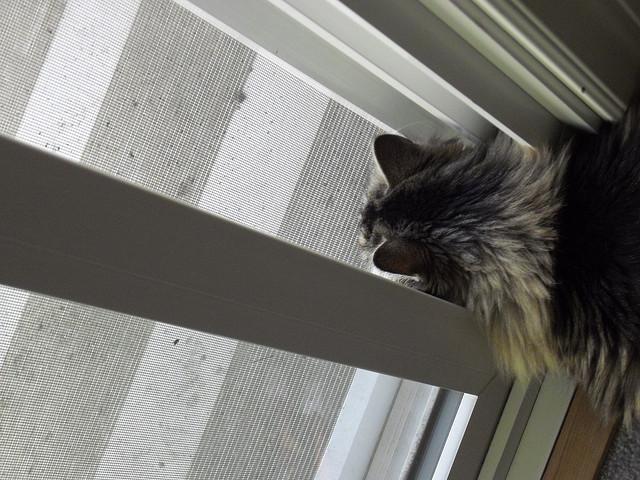Is the cat outside?
Quick response, please. No. Does this appear to be a new or old building?
Answer briefly. New. What color is the cloth?
Answer briefly. Gray. What is the cat looking at?
Be succinct. Outside. What animal is looking out the window?
Concise answer only. Cat. Where is the cat's head?
Be succinct. Window. Is there a screen?
Give a very brief answer. Yes. What is the cat sitting on?
Answer briefly. Floor. 